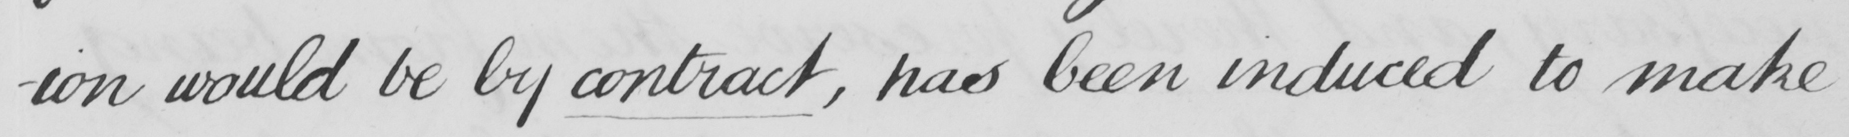What is written in this line of handwriting? -ion would be by contract , has been induced to make 